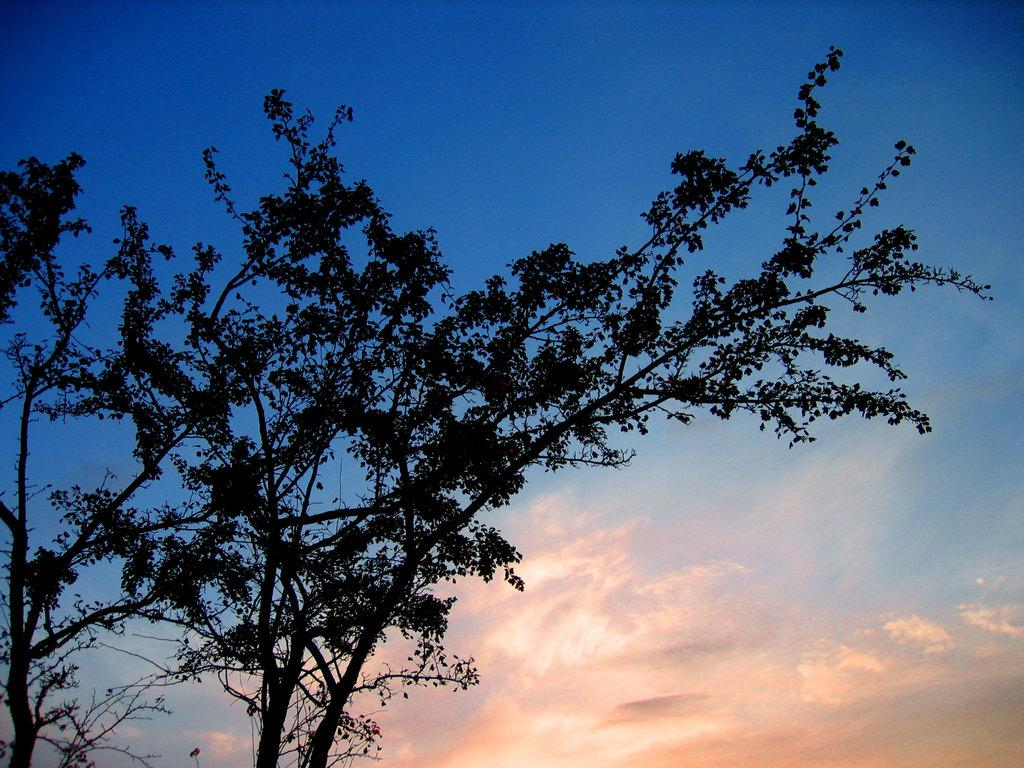What type of vegetation can be seen in the image? There are trees in the image. What is visible in the background of the image? The sky is visible in the background of the image. What is the color of the sky in the image? The color of the sky is blue. What can be seen at the bottom of the image? Clouds are present at the bottom of the image. What type of pan is hanging on the wall in the image? There is no pan or wall present in the image; it only features trees, the sky, and clouds. 